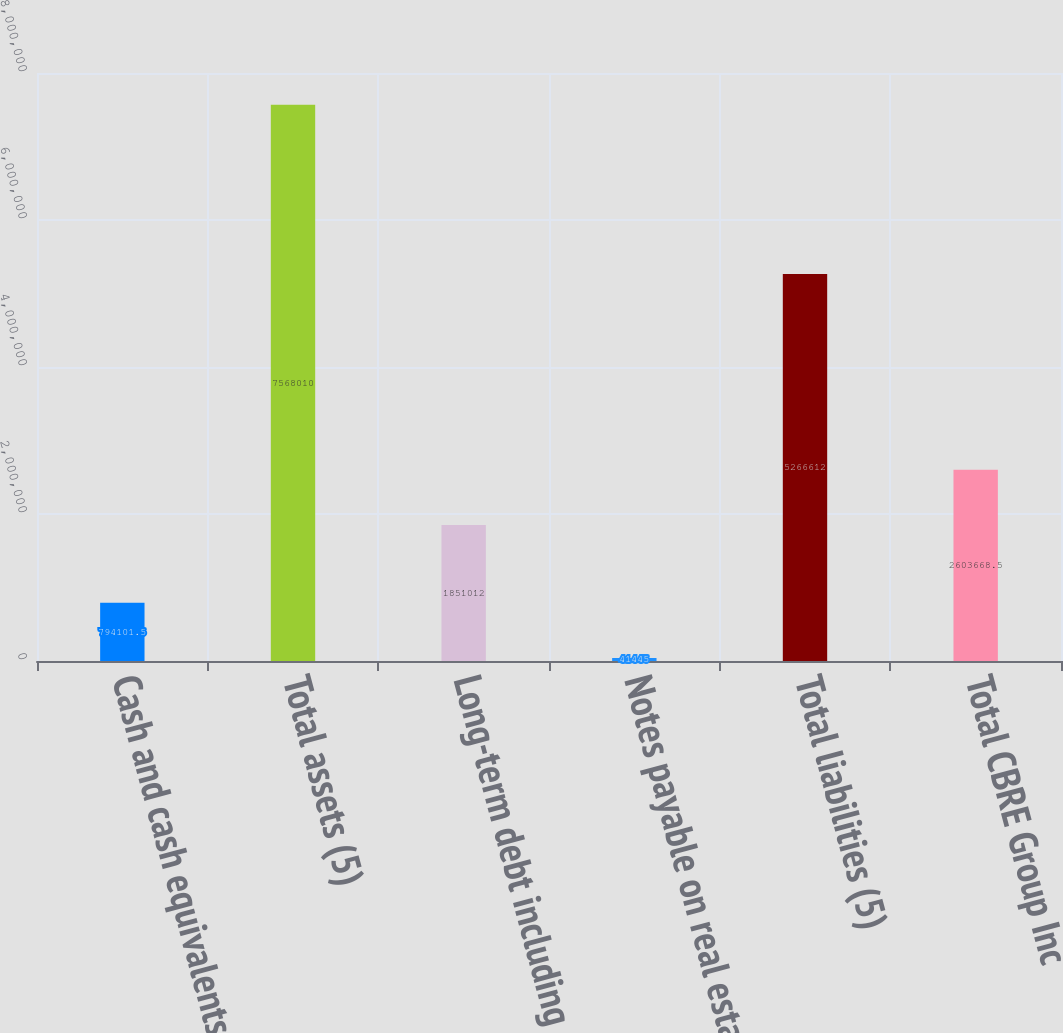<chart> <loc_0><loc_0><loc_500><loc_500><bar_chart><fcel>Cash and cash equivalents<fcel>Total assets (5)<fcel>Long-term debt including<fcel>Notes payable on real estate<fcel>Total liabilities (5)<fcel>Total CBRE Group Inc<nl><fcel>794102<fcel>7.56801e+06<fcel>1.85101e+06<fcel>41445<fcel>5.26661e+06<fcel>2.60367e+06<nl></chart> 